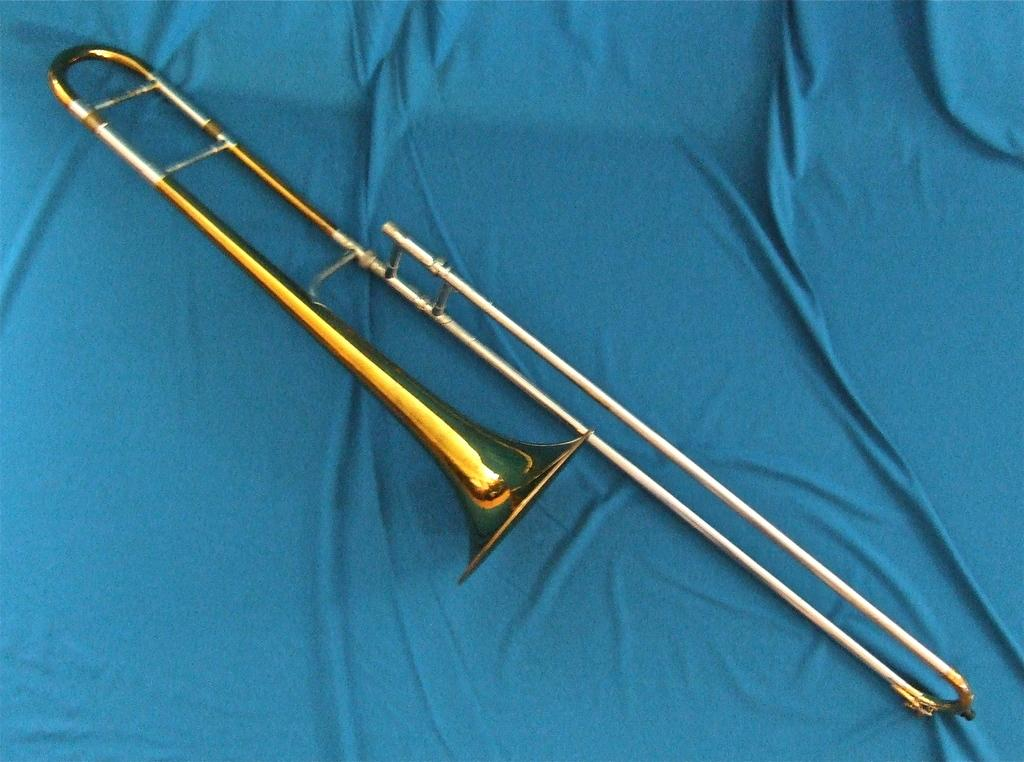What musical instrument is present in the image? There is a flute in the picture. Where is the flute located? The flute is on the bed. What color is the bed-sheet in the image? There is a blue bed-sheet in the picture. What type of button can be seen on the flute in the image? There is no button present on the flute in the image. What kind of grain is visible on the bed-sheet in the image? There is no grain visible on the bed-sheet in the image; it is a solid blue color. 